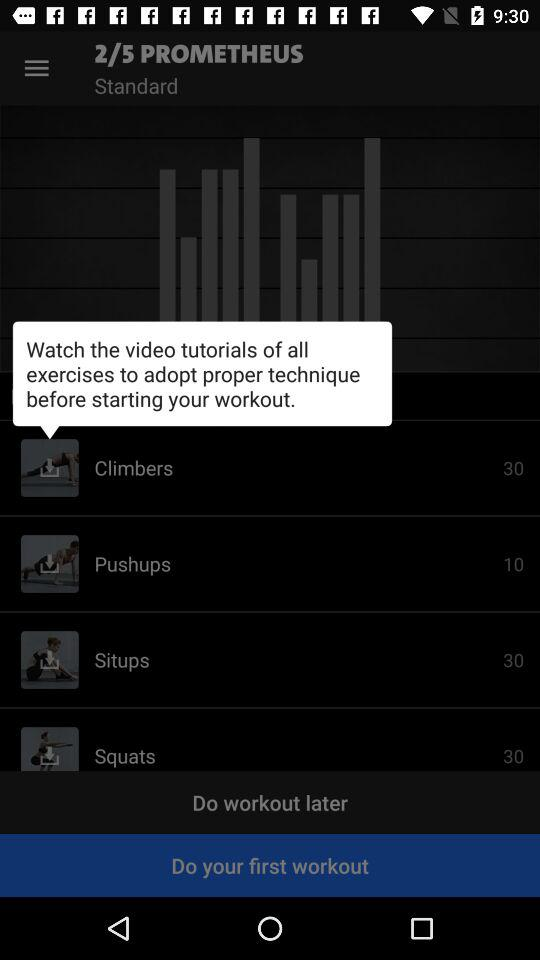What is the number of reps in pushups? The number of reps in pushups is 10. 